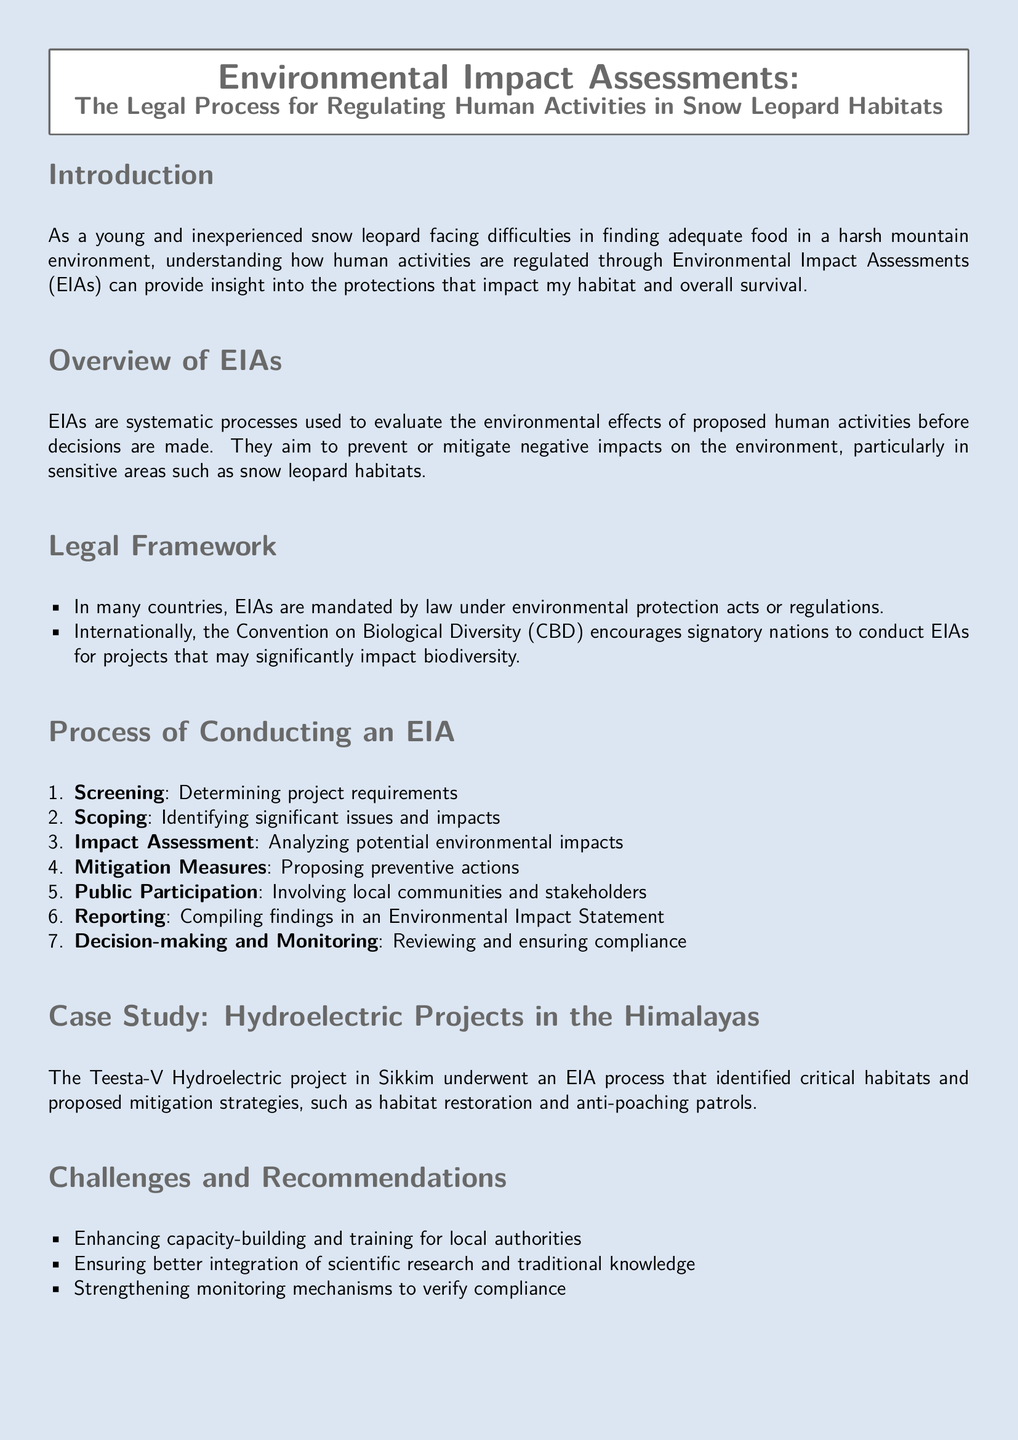what is the purpose of EIAs? EIAs aim to prevent or mitigate negative impacts on the environment, particularly in sensitive areas such as snow leopard habitats.
Answer: prevent or mitigate negative impacts what is the first step in the EIA process? The first step in the EIA process is Screening, which determines project requirements.
Answer: Screening which international agreement encourages EIAs? The Convention on Biological Diversity (CBD) encourages signatory nations to conduct EIAs for projects that may significantly impact biodiversity.
Answer: Convention on Biological Diversity what was identified during the EIA for the Teesta-V Hydroelectric project? The EIA for the Teesta-V Hydroelectric project identified critical habitats and proposed mitigation strategies.
Answer: critical habitats what is one recommendation for improving EIAs? One recommendation for improving EIAs is enhancing capacity-building and training for local authorities.
Answer: enhancing capacity-building how many steps are there in the EIA process? There are seven steps in the EIA process as outlined in the document.
Answer: seven 